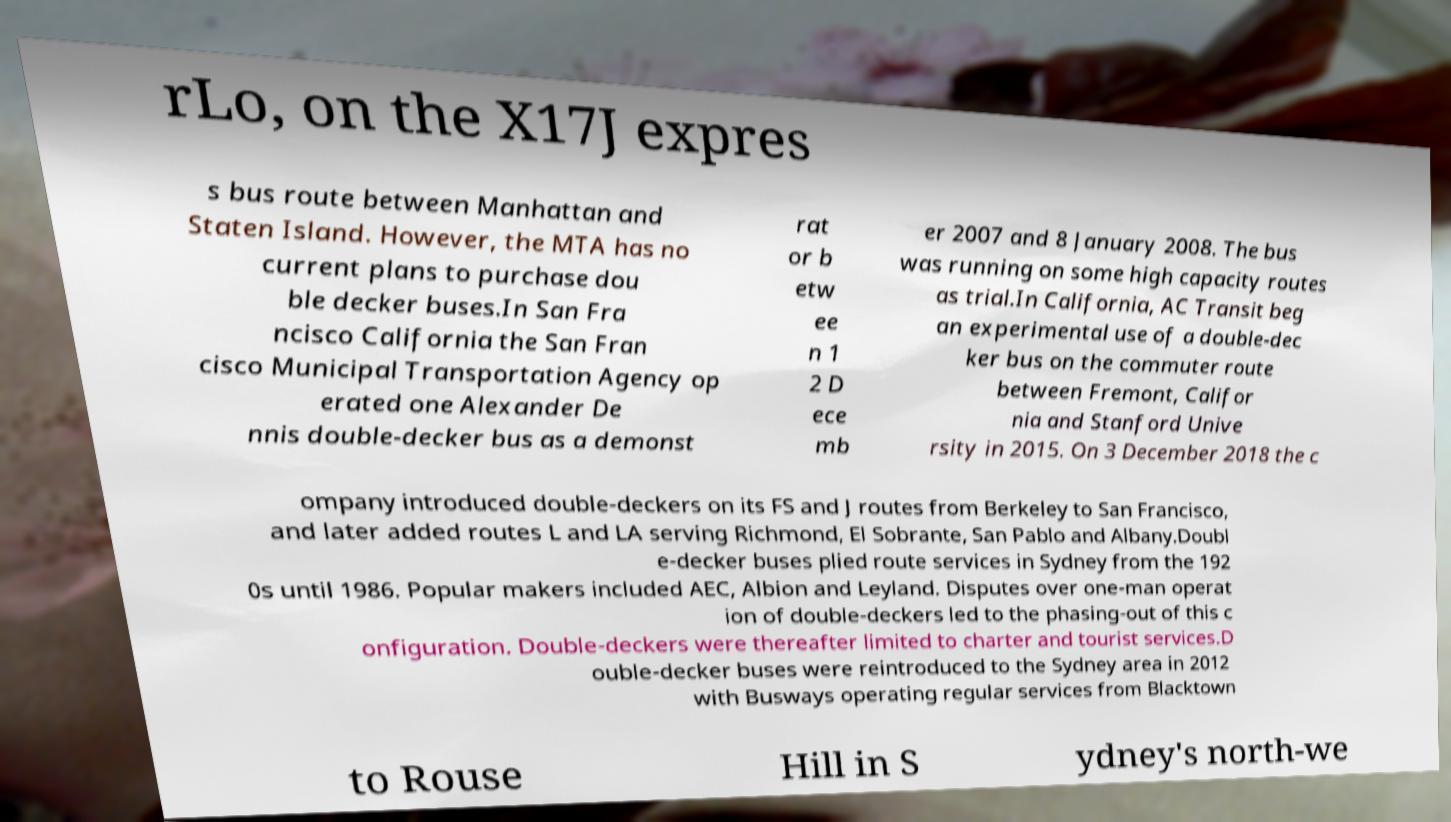There's text embedded in this image that I need extracted. Can you transcribe it verbatim? rLo, on the X17J expres s bus route between Manhattan and Staten Island. However, the MTA has no current plans to purchase dou ble decker buses.In San Fra ncisco California the San Fran cisco Municipal Transportation Agency op erated one Alexander De nnis double-decker bus as a demonst rat or b etw ee n 1 2 D ece mb er 2007 and 8 January 2008. The bus was running on some high capacity routes as trial.In California, AC Transit beg an experimental use of a double-dec ker bus on the commuter route between Fremont, Califor nia and Stanford Unive rsity in 2015. On 3 December 2018 the c ompany introduced double-deckers on its FS and J routes from Berkeley to San Francisco, and later added routes L and LA serving Richmond, El Sobrante, San Pablo and Albany.Doubl e-decker buses plied route services in Sydney from the 192 0s until 1986. Popular makers included AEC, Albion and Leyland. Disputes over one-man operat ion of double-deckers led to the phasing-out of this c onfiguration. Double-deckers were thereafter limited to charter and tourist services.D ouble-decker buses were reintroduced to the Sydney area in 2012 with Busways operating regular services from Blacktown to Rouse Hill in S ydney's north-we 